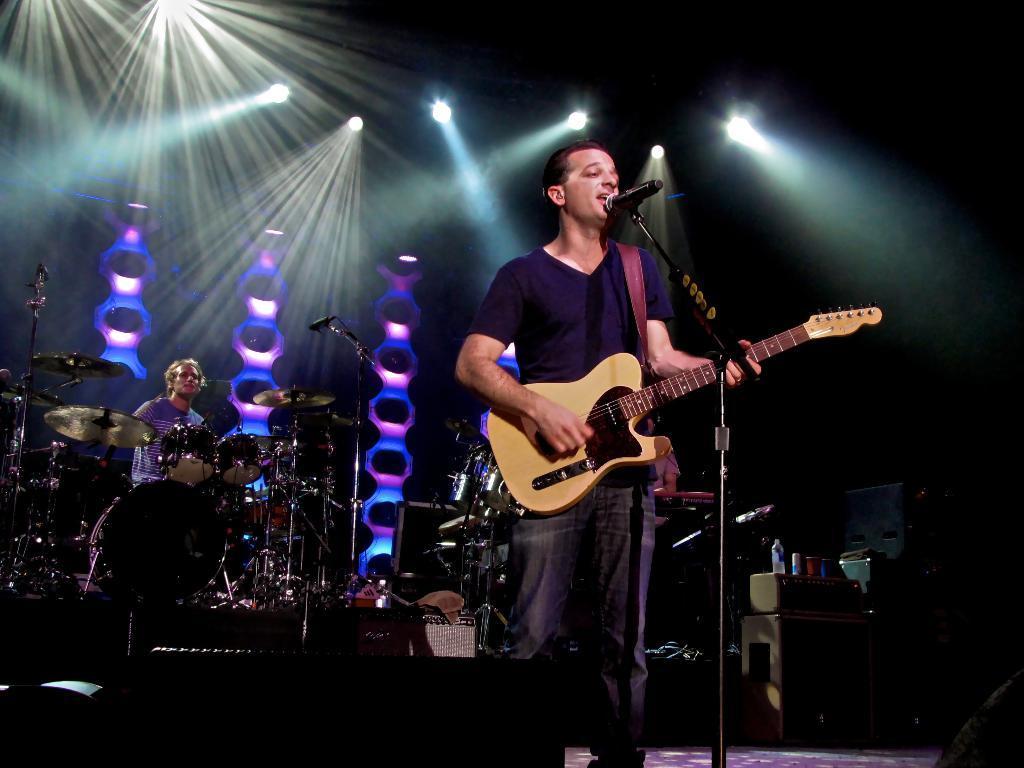How would you summarize this image in a sentence or two? We can see in the background there is a man,lighting and decoration part. He is standing his holding a guitar. His singing a song we can see his mouth is open. 